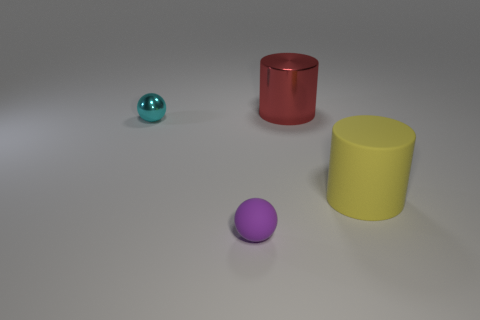Do the objects have any texture or are they smooth? The objects in the image all appear to have a smooth, matte finish. There's no discernible texture such as bumps or roughness visible on the surfaces, indicating that they might be designed to look sleek and simple. 